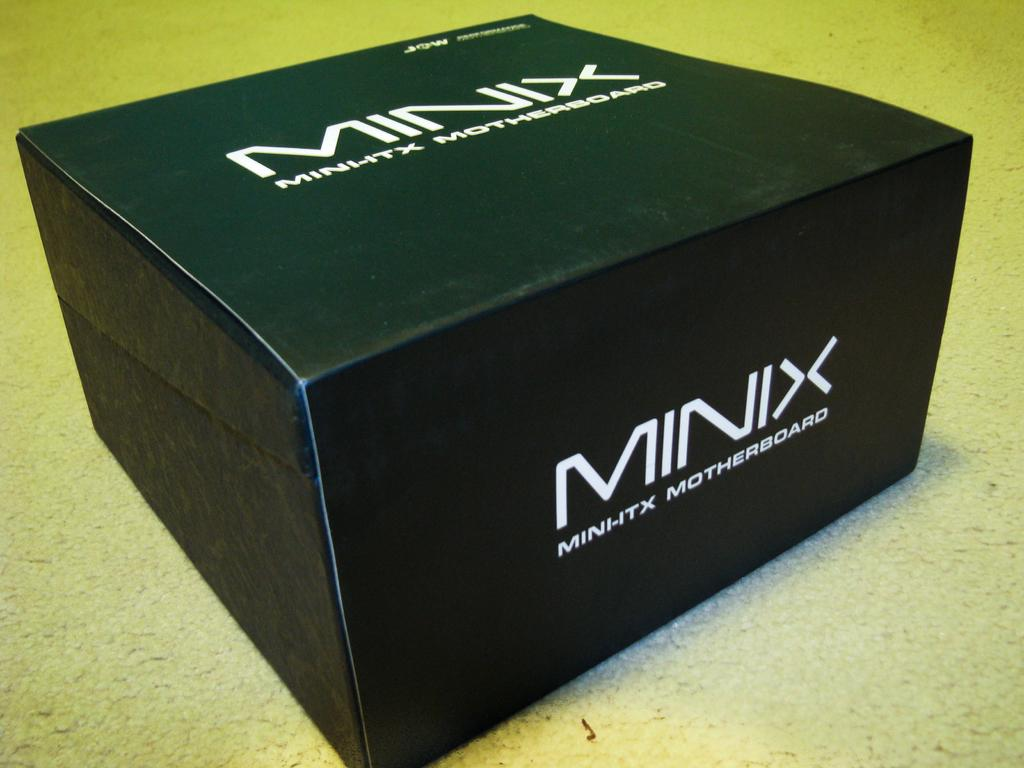<image>
Give a short and clear explanation of the subsequent image. A black box with the writing Minix Mini-Itz Motherboard. 